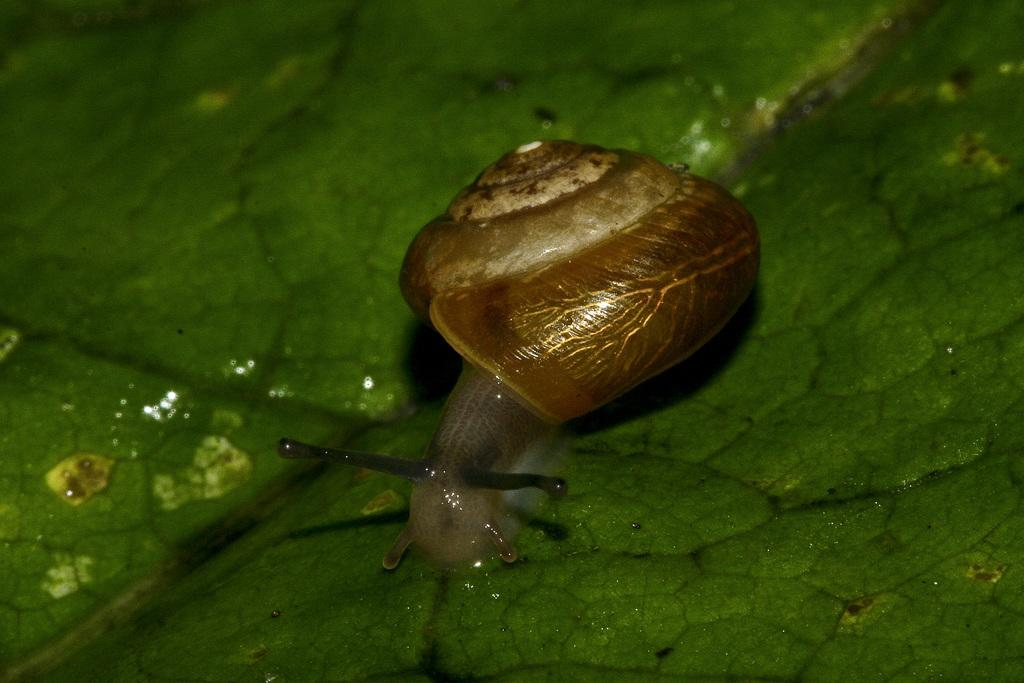What type of animal is in the image? There is a snail in the image. What is the snail resting on in the image? The snail is on a green surface. How many fangs does the snail have in the image? Snails do not have fangs, so this question cannot be answered based on the image. 